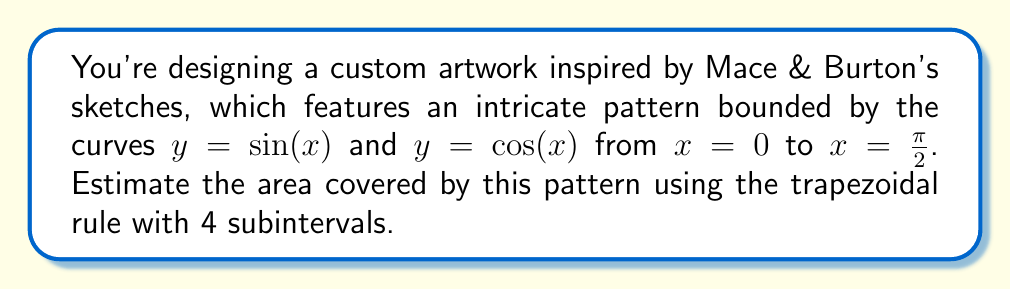Can you solve this math problem? Let's approach this step-by-step:

1) The area we're trying to estimate is between $y = \sin(x)$ and $y = \cos(x)$ from $x = 0$ to $x = \frac{\pi}{2}$. This can be represented by the integral:

   $$A = \int_0^{\frac{\pi}{2}} (\cos(x) - \sin(x)) dx$$

2) To apply the trapezoidal rule with 4 subintervals, we need to divide the interval $[0, \frac{\pi}{2}]$ into 4 equal parts. The width of each subinterval is:

   $$\Delta x = \frac{\frac{\pi}{2} - 0}{4} = \frac{\pi}{8}$$

3) We need to evaluate $f(x) = \cos(x) - \sin(x)$ at $x = 0, \frac{\pi}{8}, \frac{\pi}{4}, \frac{3\pi}{8},$ and $\frac{\pi}{2}$:

   $f(0) = 1 - 0 = 1$
   $f(\frac{\pi}{8}) \approx 0.7071 - 0.3827 = 0.3244$
   $f(\frac{\pi}{4}) = \frac{\sqrt{2}}{2} - \frac{\sqrt{2}}{2} = 0$
   $f(\frac{3\pi}{8}) \approx 0.3827 - 0.7071 = -0.3244$
   $f(\frac{\pi}{2}) = 0 - 1 = -1$

4) The trapezoidal rule formula is:

   $$A \approx \frac{\Delta x}{2}[f(x_0) + 2f(x_1) + 2f(x_2) + 2f(x_3) + f(x_4)]$$

5) Substituting our values:

   $$A \approx \frac{\pi}{16}[1 + 2(0.3244) + 2(0) + 2(-0.3244) + (-1)]$$
   $$A \approx \frac{\pi}{16}[0]$$
   $$A \approx 0$$

6) Therefore, our estimate of the area is approximately 0 square units.
Answer: 0 square units 